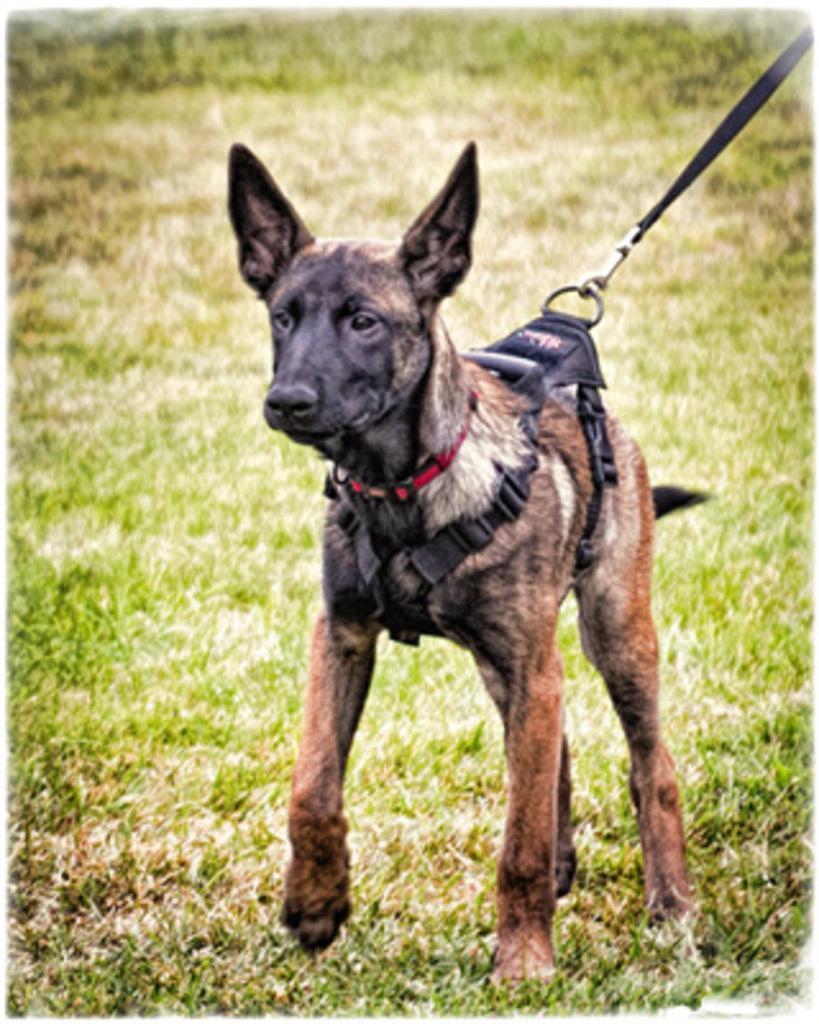How would you summarize this image in a sentence or two? In this picture, we see a dog. It is in black and brown color. We see the leash of the dog in red and black color. At the bottom, we see the grass. In the background, we see the grass. This picture might be a photo frame. 